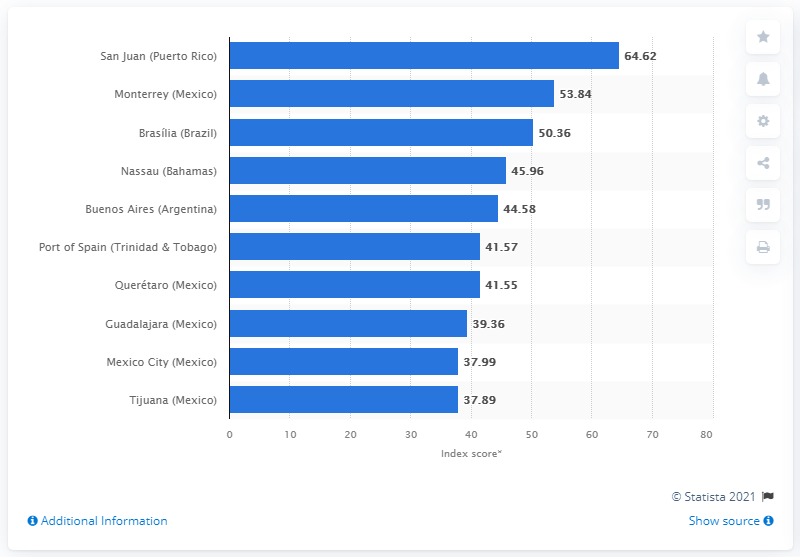Identify some key points in this picture. The index score for Monterrey was 53.84. Brasilia's index score for the first half of 2020 was 50.36. 